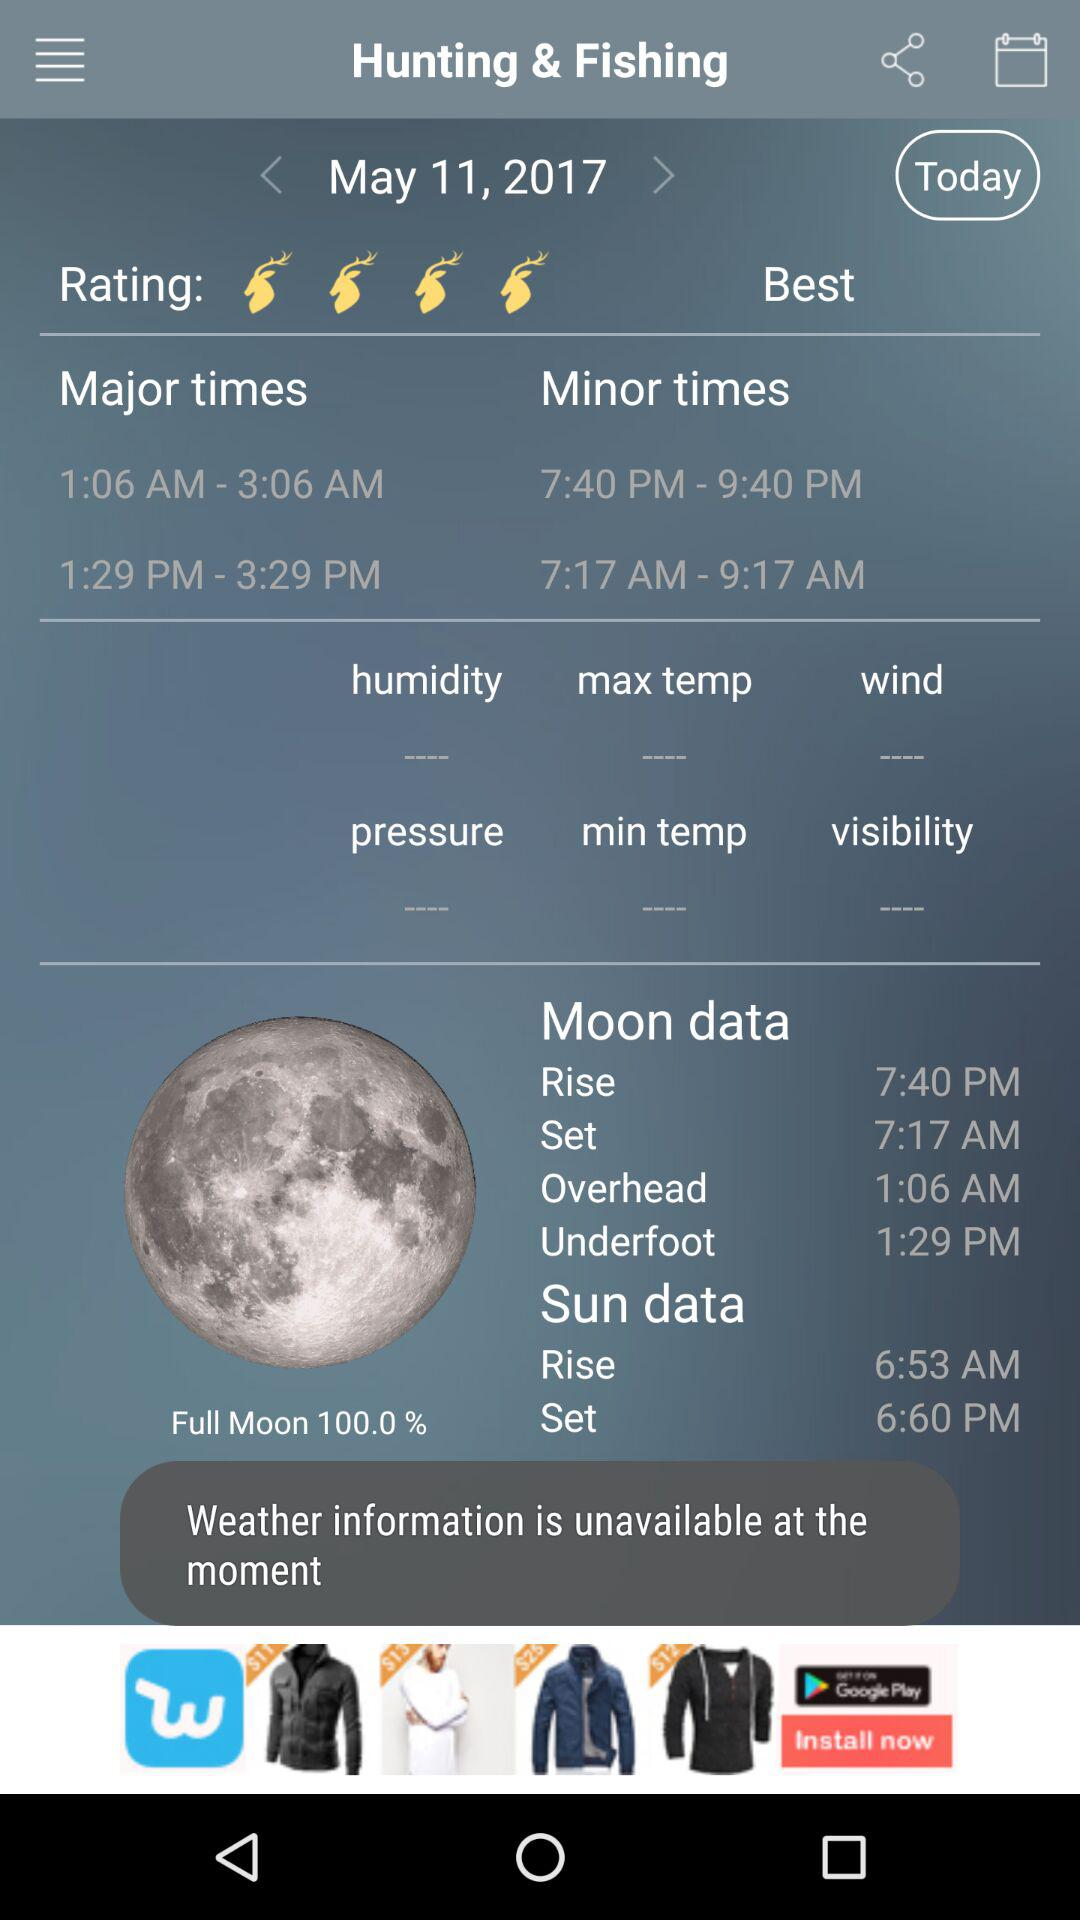What is the rating? The rating is 4 deers. 